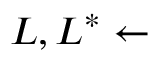<formula> <loc_0><loc_0><loc_500><loc_500>L , L ^ { \ast } \gets</formula> 